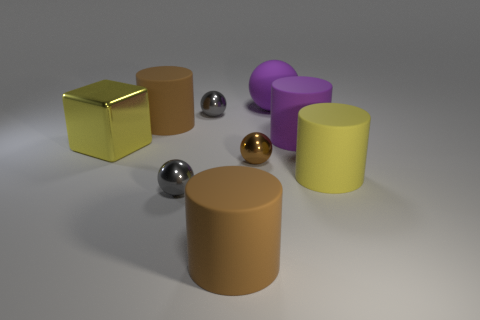Are there fewer brown cylinders that are in front of the brown metal sphere than big red cylinders?
Provide a short and direct response. No. There is a yellow cylinder behind the tiny gray ball that is in front of the yellow cylinder; how big is it?
Give a very brief answer. Large. How many objects are either purple cubes or yellow metallic blocks?
Ensure brevity in your answer.  1. Are there any other spheres that have the same color as the big sphere?
Make the answer very short. No. Are there fewer tiny yellow shiny cylinders than large purple matte objects?
Provide a succinct answer. Yes. How many things are either spheres or big matte cylinders that are in front of the large cube?
Your answer should be very brief. 6. Are there any large brown spheres made of the same material as the big cube?
Provide a succinct answer. No. There is a purple cylinder that is the same size as the yellow cylinder; what material is it?
Ensure brevity in your answer.  Rubber. The brown cylinder that is in front of the purple object in front of the purple rubber ball is made of what material?
Offer a very short reply. Rubber. Is the shape of the large yellow object that is left of the large purple rubber cylinder the same as  the tiny brown object?
Your answer should be compact. No. 